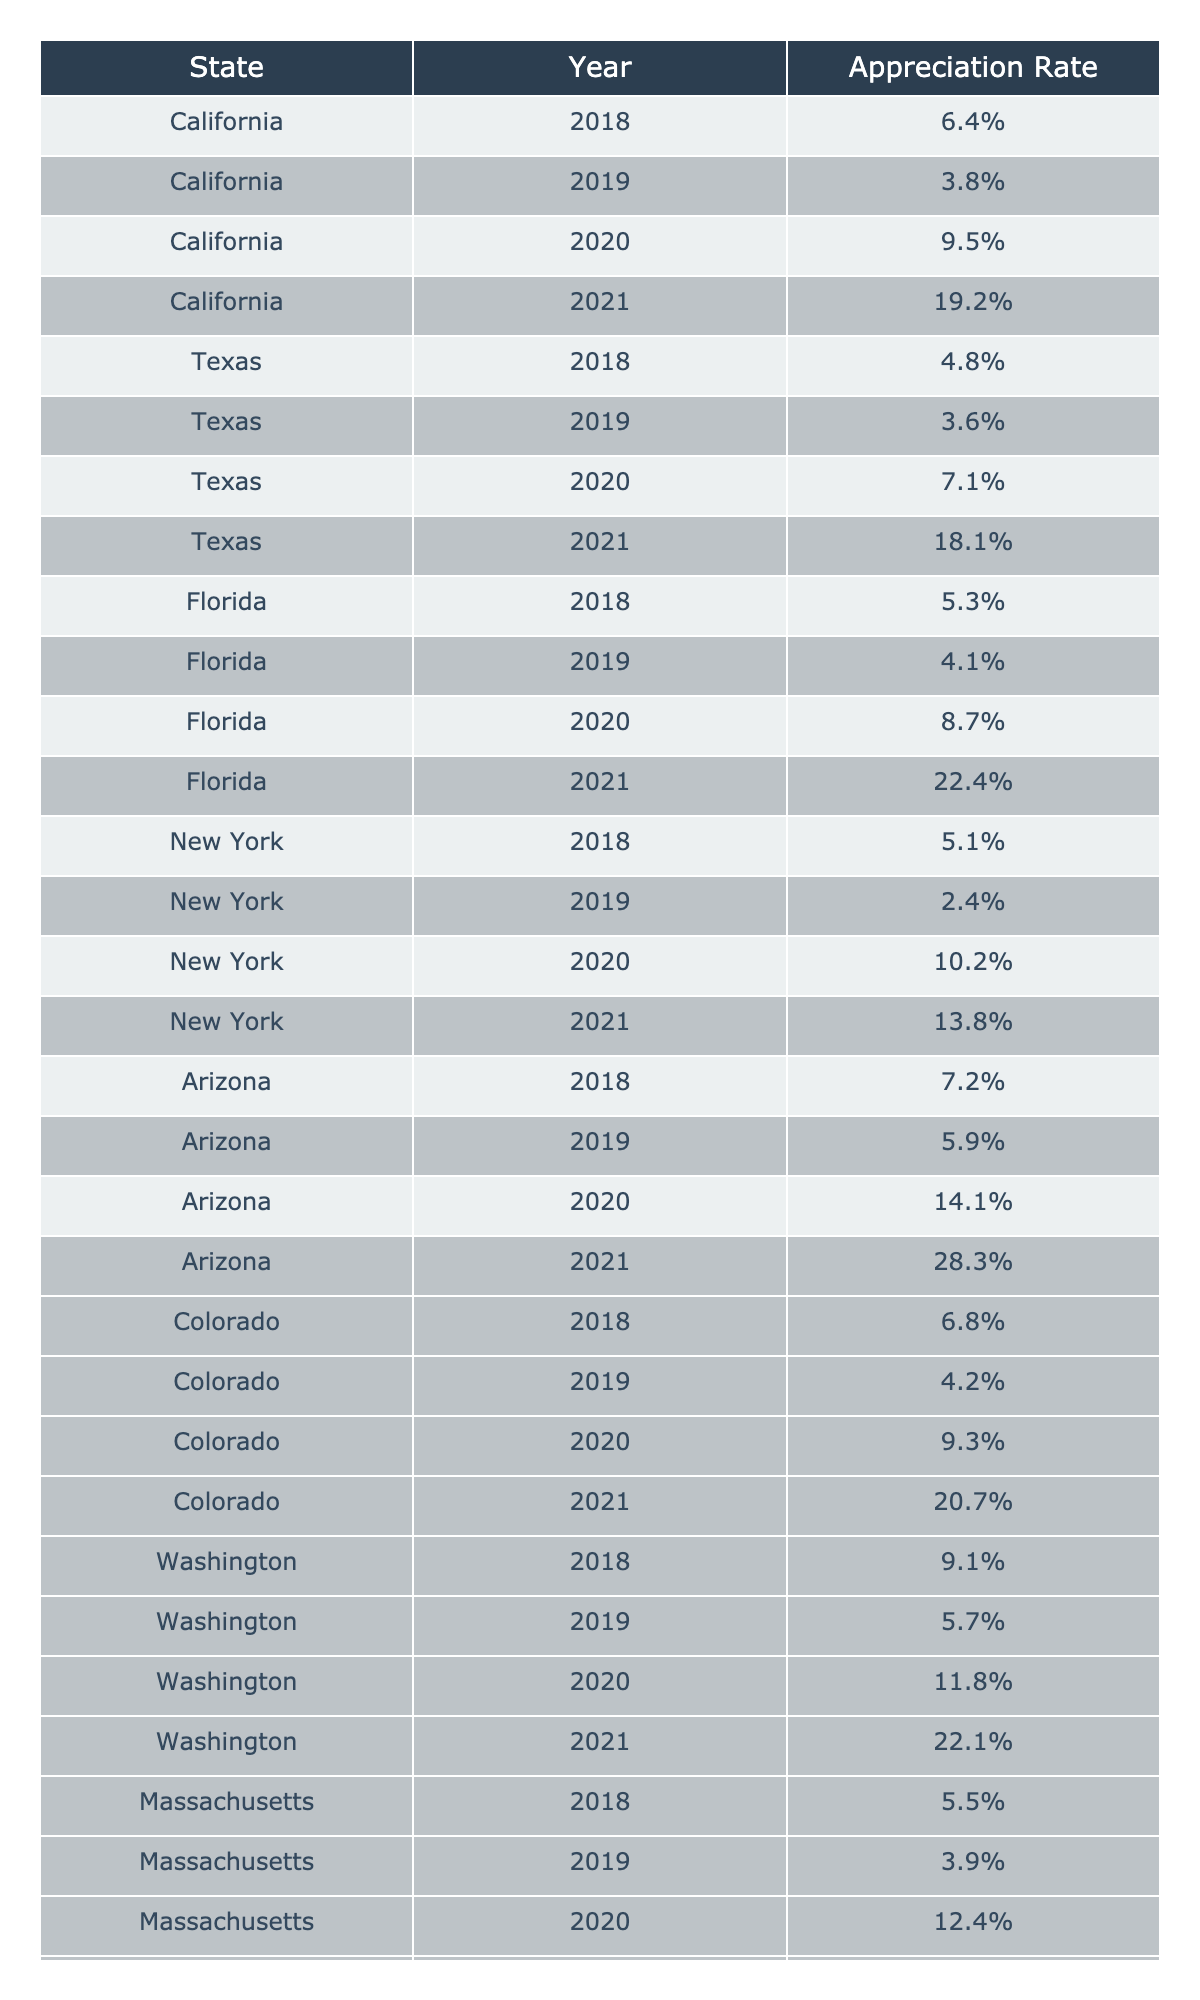What was the appreciation rate for Arizona in 2021? The table shows the appreciation rate for each state and year. For Arizona, the row corresponding to the year 2021 indicates an appreciation rate of 28.3%.
Answer: 28.3% Which state had the highest appreciation rate in 2020? Looking at the table for the year 2020, the appreciation rates are listed as follows: California (9.5%), Texas (7.1%), Florida (8.7%), New York (10.2%), Arizona (14.1%), Colorado (9.3%), Washington (11.8%), and Massachusetts (12.4%). The highest rate among these is Arizona at 14.1%.
Answer: Arizona What is the average appreciation rate for California from 2018 to 2021? To find the average appreciation rate for California, we add the rates: 6.4% + 3.8% + 9.5% + 19.2% = 38.9%. There are 4 years, so we divide 38.9% by 4 to get an average of 9.725%.
Answer: 9.7% Did Florida's appreciation rate ever exceed 10% in 2021? The table shows Florida’s appreciation rates: 5.3% (2018), 4.1% (2019), 8.7% (2020), and 22.4% (2021). In 2021, the rate was 22.4%, which exceeds 10%.
Answer: Yes What was the difference in appreciation rates between Colorado and Texas in 2020? In 2020, Colorado had an appreciation rate of 9.3% and Texas had 7.1%. The difference can be calculated by subtracting Texas's rate from Colorado's: 9.3% - 7.1% = 2.2%.
Answer: 2.2% Which state showed the largest increase in appreciation rate from 2018 to 2021? We need to calculate the appreciation rates for each state from the starting year (2018) to the ending year (2021). For example, California's rate increased from 6.4% to 19.2% (an increase of 12.8%), Texas from 4.8% to 18.1% (13.3%), Florida from 5.3% to 22.4% (17.1%), and so on. Arizona had an increase from 7.2% to 28.3%, which totals 21.1%. Comparing all increases, Arizona has the highest increase of 21.1%.
Answer: Arizona In which year did New York experience its lowest appreciation rate? By checking the appreciation rates for New York from 2018 to 2021, we see that they are 5.1% (2018), 2.4% (2019), 10.2% (2020), and 13.8% (2021). The rate was lowest in 2019 at 2.4%.
Answer: 2019 What was the highest appreciation rate recorded across all states in 2021? In 2021, the appreciation rates for each state were: California (19.2%), Texas (18.1%), Florida (22.4%), New York (13.8%), Arizona (28.3%), Colorado (20.7%), Washington (22.1%), Massachusetts (16.2%). The maximum appreciation rate was 28.3% from Arizona.
Answer: 28.3% Which state had a consistently lower appreciation rate through 2021: Massachusetts or New York? Evaluating the appreciation rates listed for Massachusetts (5.5%, 3.9%, 12.4%, 16.2%) and New York (5.1%, 2.4%, 10.2%, 13.8%), we see that New York had lower rates in both 2018 (5.1% vs. 5.5%) and 2019 (2.4% vs. 3.9%), while Massachusetts had higher rates in 2020 and 2021, thus confirming that New York was consistently lower through 2021.
Answer: New York 